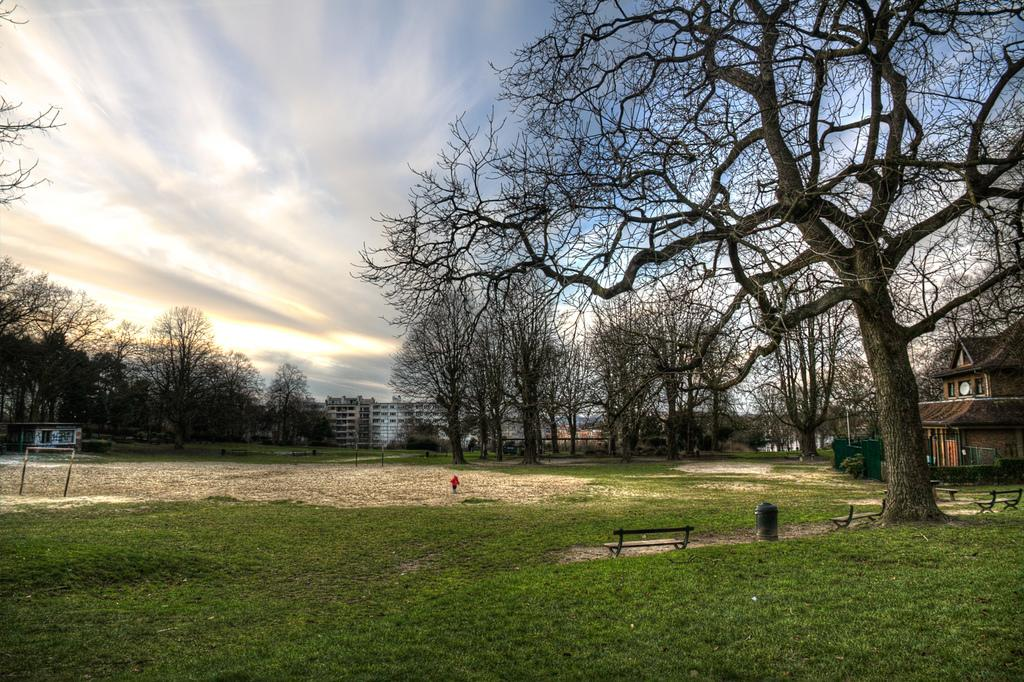What type of view is shown in the image? The image has an outside view. What can be seen in the foreground of the image? There are trees in the foreground of the image. Where is the house located in the image? The house is on the right side of the image. What is visible in the background of the image? The sky is visible in the background of the image. How many feet are visible in the image? There are no feet visible in the image; it shows an outside view with trees, a house, and the sky. 